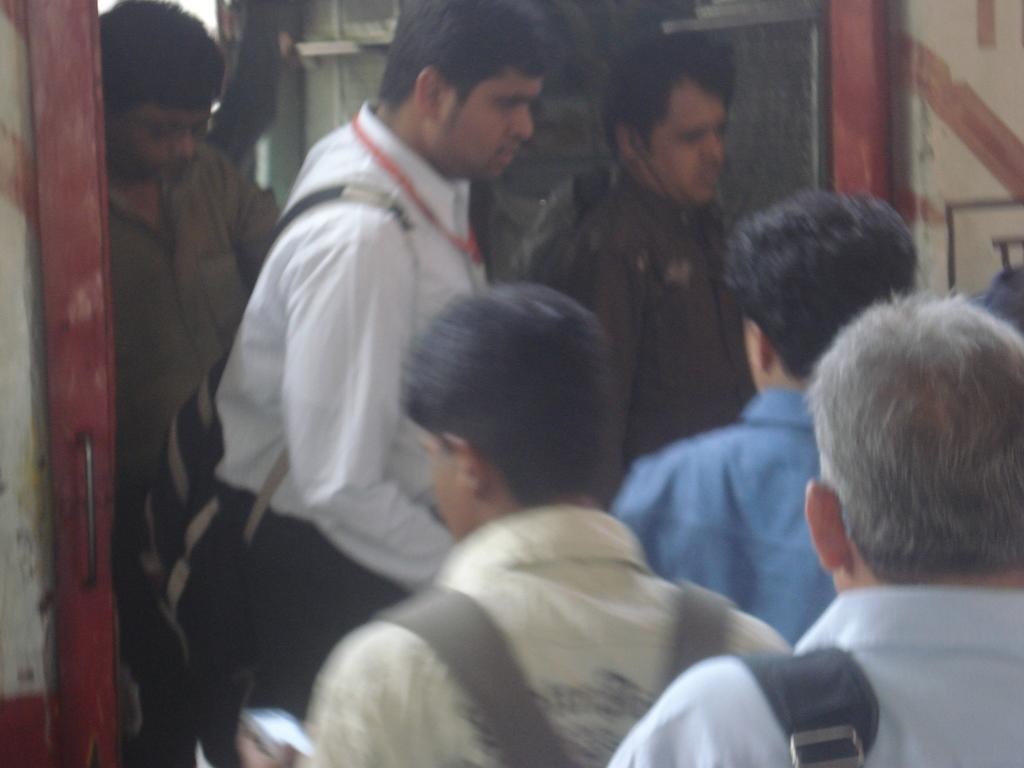How many people are in the image? There is a group of persons in the image. What are some of the people in the image doing? Some of the persons are standing, and some are walking. What are the hobbies of the people in the image? There is no information about the hobbies of the people in the image. 